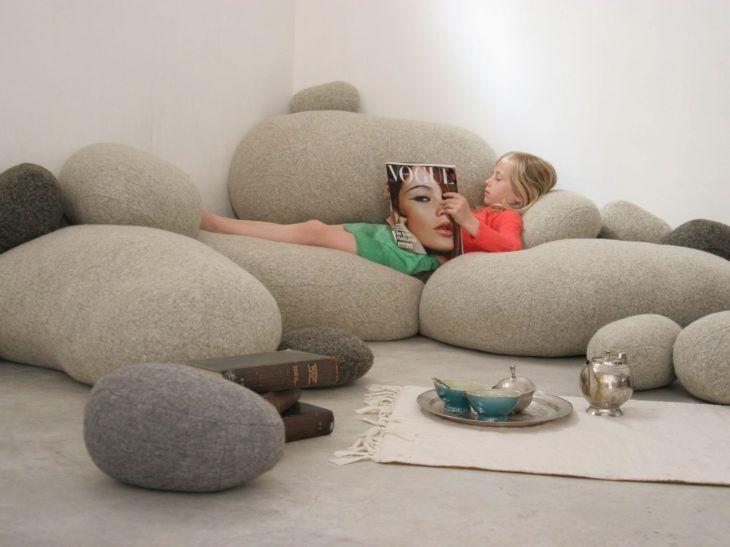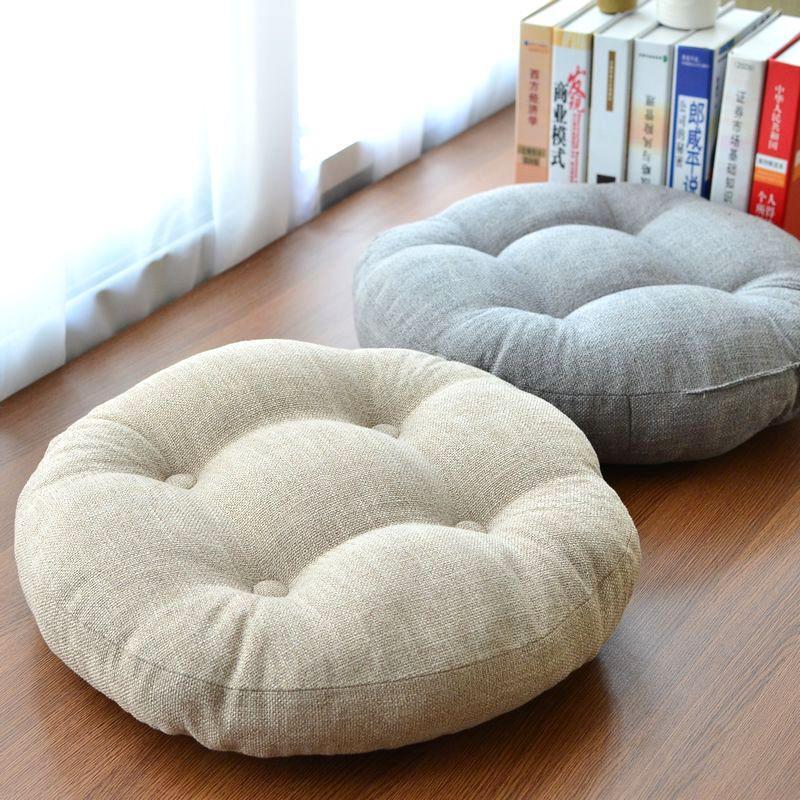The first image is the image on the left, the second image is the image on the right. Evaluate the accuracy of this statement regarding the images: "An image shows a room featuring bright yellowish furniture.". Is it true? Answer yes or no. No. 